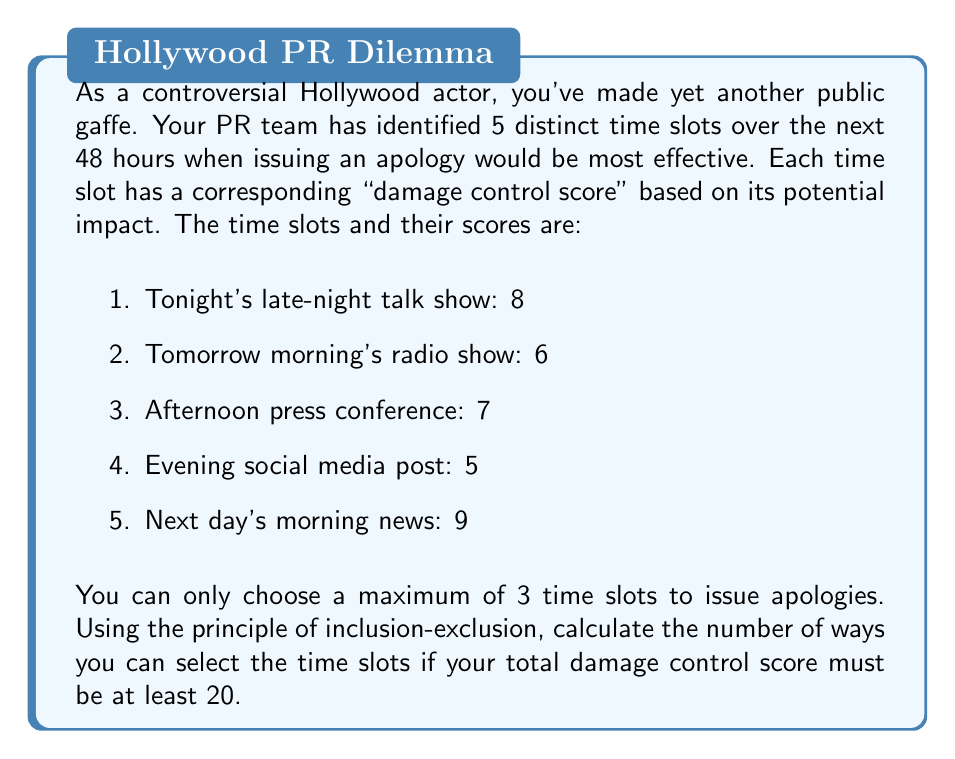Show me your answer to this math problem. Let's approach this step-by-step using the principle of inclusion-exclusion and set theory:

1) First, let's define our universe $U$ as all possible combinations of choosing up to 3 time slots out of 5. This can be calculated as:

   $|U| = \binom{5}{1} + \binom{5}{2} + \binom{5}{3} = 5 + 10 + 10 = 25$

2) Now, let $A$ be the set of all combinations with a total score of at least 20. We need to find $|A|$.

3) It's easier to calculate $|A^c|$, the complement of $A$, which represents all combinations with a score less than 20.

4) Let's define subsets:
   $B_1$: Combinations including slot 1 (score 8)
   $B_2$: Combinations including slot 2 (score 6)
   $B_3$: Combinations including slot 3 (score 7)
   $B_4$: Combinations including slot 4 (score 5)
   $B_5$: Combinations including slot 5 (score 9)

5) Using the principle of inclusion-exclusion:

   $|A^c| = |B_1 \cup B_2 \cup B_3 \cup B_4| = \sum_{i} |B_i| - \sum_{i<j} |B_i \cap B_j| + \sum_{i<j<k} |B_i \cap B_j \cap B_k|$

6) Calculating each term:
   $|B_1| = |B_2| = |B_3| = |B_4| = 4$ (each can be paired with any of the other 4 slots)
   $|B_1 \cap B_2| = |B_1 \cap B_3| = |B_1 \cap B_4| = |B_2 \cap B_3| = |B_2 \cap B_4| = |B_3 \cap B_4| = 1$
   $|B_1 \cap B_2 \cap B_3| = |B_1 \cap B_2 \cap B_4| = |B_1 \cap B_3 \cap B_4| = |B_2 \cap B_3 \cap B_4| = 0$

7) Substituting:
   $|A^c| = (4+4+4+4) - (1+1+1+1+1+1) + 0 = 16 - 6 = 10$

8) Therefore, $|A| = |U| - |A^c| = 25 - 10 = 15$

Thus, there are 15 ways to select the time slots with a total damage control score of at least 20.
Answer: 15 ways 